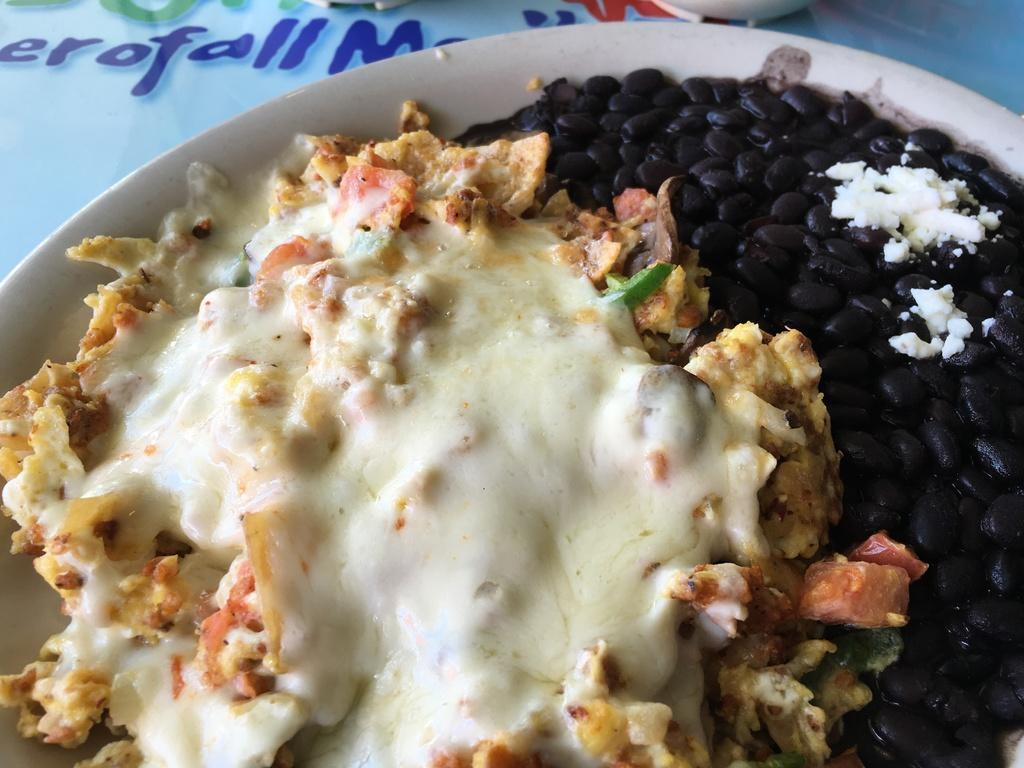What is the main subject of the image? The main subject of the image is a food item served in a plate. What can be seen at the top of the image? There is text and a white color object at the top of the image. What type of orange is being discussed by the judge in the image? There is no orange, discussion, or judge present in the image. 